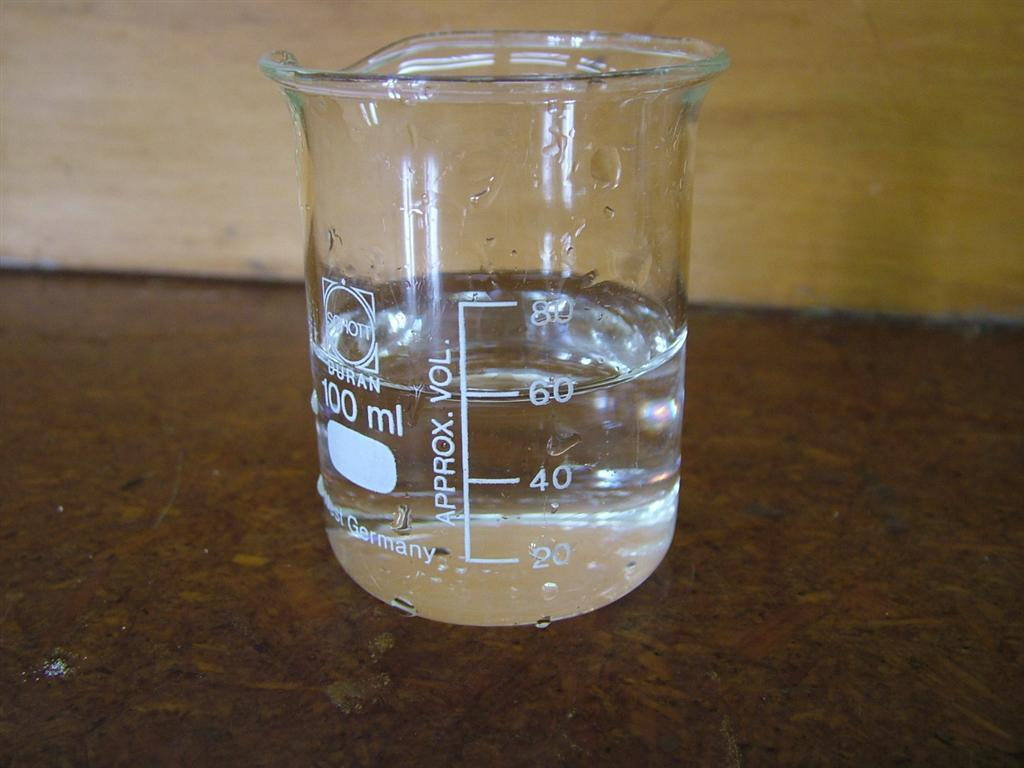<image>
Provide a brief description of the given image. A 100 ml beaker is half full of water. 